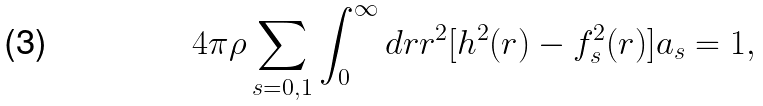<formula> <loc_0><loc_0><loc_500><loc_500>4 \pi \rho \sum _ { s = 0 , 1 } \int _ { 0 } ^ { \infty } d r r ^ { 2 } [ h ^ { 2 } ( r ) - f _ { s } ^ { 2 } ( r ) ] a _ { s } = 1 ,</formula> 